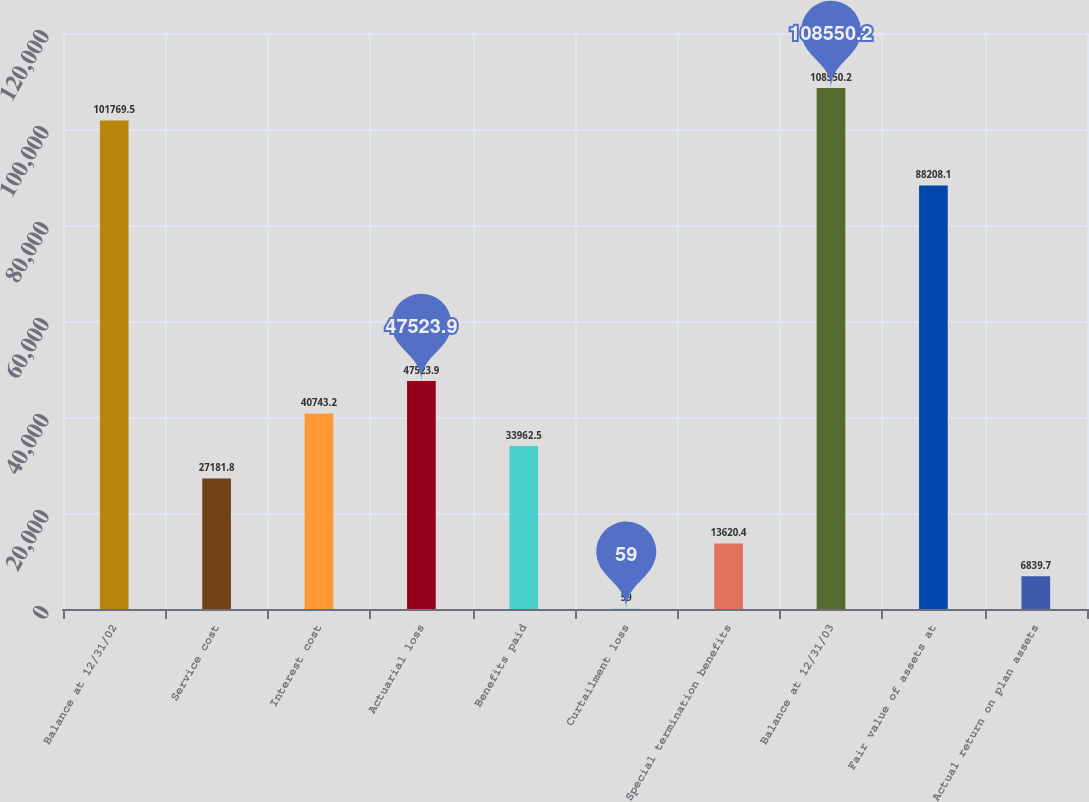Convert chart to OTSL. <chart><loc_0><loc_0><loc_500><loc_500><bar_chart><fcel>Balance at 12/31/02<fcel>Service cost<fcel>Interest cost<fcel>Actuarial loss<fcel>Benefits paid<fcel>Curtailment loss<fcel>Special termination benefits<fcel>Balance at 12/31/03<fcel>Fair value of assets at<fcel>Actual return on plan assets<nl><fcel>101770<fcel>27181.8<fcel>40743.2<fcel>47523.9<fcel>33962.5<fcel>59<fcel>13620.4<fcel>108550<fcel>88208.1<fcel>6839.7<nl></chart> 